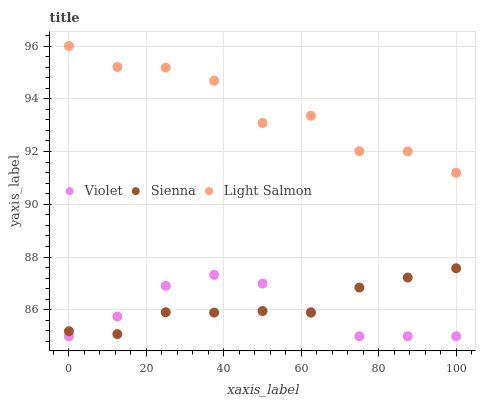Does Violet have the minimum area under the curve?
Answer yes or no. Yes. Does Light Salmon have the maximum area under the curve?
Answer yes or no. Yes. Does Light Salmon have the minimum area under the curve?
Answer yes or no. No. Does Violet have the maximum area under the curve?
Answer yes or no. No. Is Sienna the smoothest?
Answer yes or no. Yes. Is Light Salmon the roughest?
Answer yes or no. Yes. Is Violet the smoothest?
Answer yes or no. No. Is Violet the roughest?
Answer yes or no. No. Does Violet have the lowest value?
Answer yes or no. Yes. Does Light Salmon have the lowest value?
Answer yes or no. No. Does Light Salmon have the highest value?
Answer yes or no. Yes. Does Violet have the highest value?
Answer yes or no. No. Is Sienna less than Light Salmon?
Answer yes or no. Yes. Is Light Salmon greater than Sienna?
Answer yes or no. Yes. Does Violet intersect Sienna?
Answer yes or no. Yes. Is Violet less than Sienna?
Answer yes or no. No. Is Violet greater than Sienna?
Answer yes or no. No. Does Sienna intersect Light Salmon?
Answer yes or no. No. 